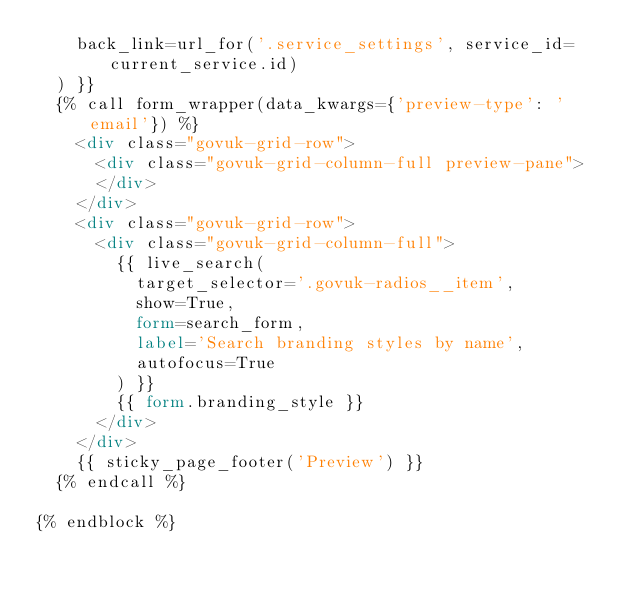<code> <loc_0><loc_0><loc_500><loc_500><_HTML_>    back_link=url_for('.service_settings', service_id=current_service.id)
  ) }}
  {% call form_wrapper(data_kwargs={'preview-type': 'email'}) %}
    <div class="govuk-grid-row">
      <div class="govuk-grid-column-full preview-pane">
      </div>
    </div>
    <div class="govuk-grid-row">
      <div class="govuk-grid-column-full">
        {{ live_search(
          target_selector='.govuk-radios__item',
          show=True,
          form=search_form,
          label='Search branding styles by name',
          autofocus=True
        ) }}
        {{ form.branding_style }}
      </div>
    </div>
    {{ sticky_page_footer('Preview') }}
  {% endcall %}

{% endblock %}
</code> 